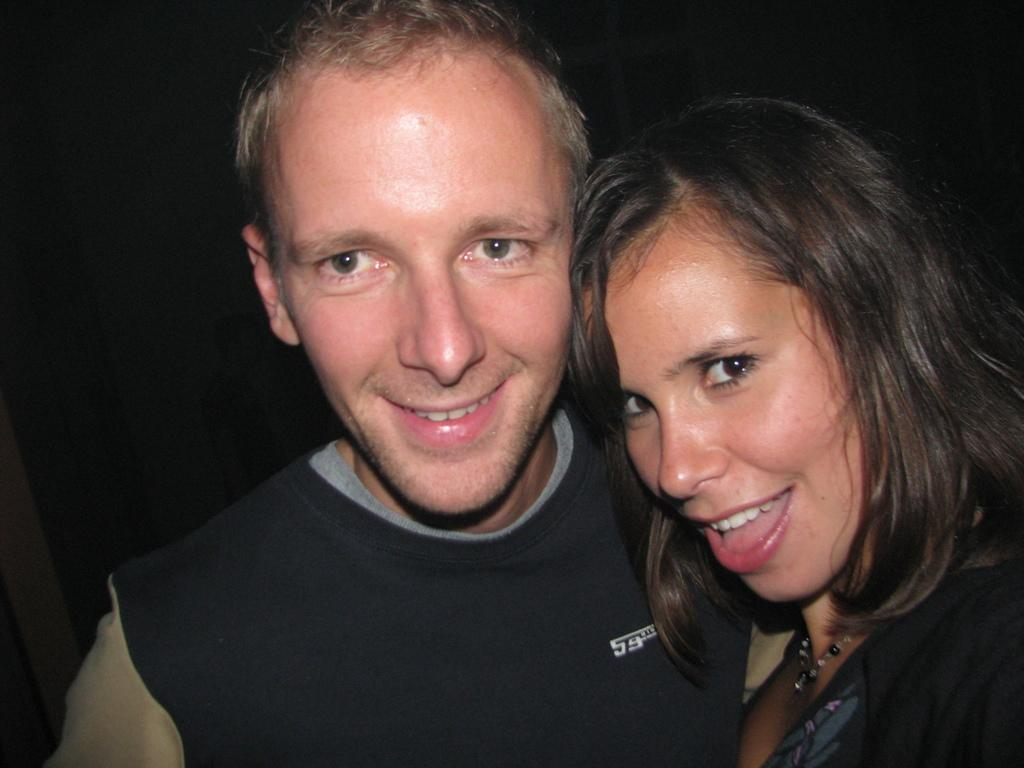Who are the people in the image? There is a woman and a man in the image. What expressions do the woman and the man have? Both the woman and the man have smiling faces. Can you describe the object in the left side corner of the image? Unfortunately, the facts provided do not give any information about the object in the left side corner of the image. What is the lighting condition in the image? The background of the image is dark. What type of tax is being discussed by the woman and the man in the image? There is no indication in the image that the woman and the man are discussing any type of tax. Can you tell me how many cubs are visible in the image? There are no cubs present in the image. 